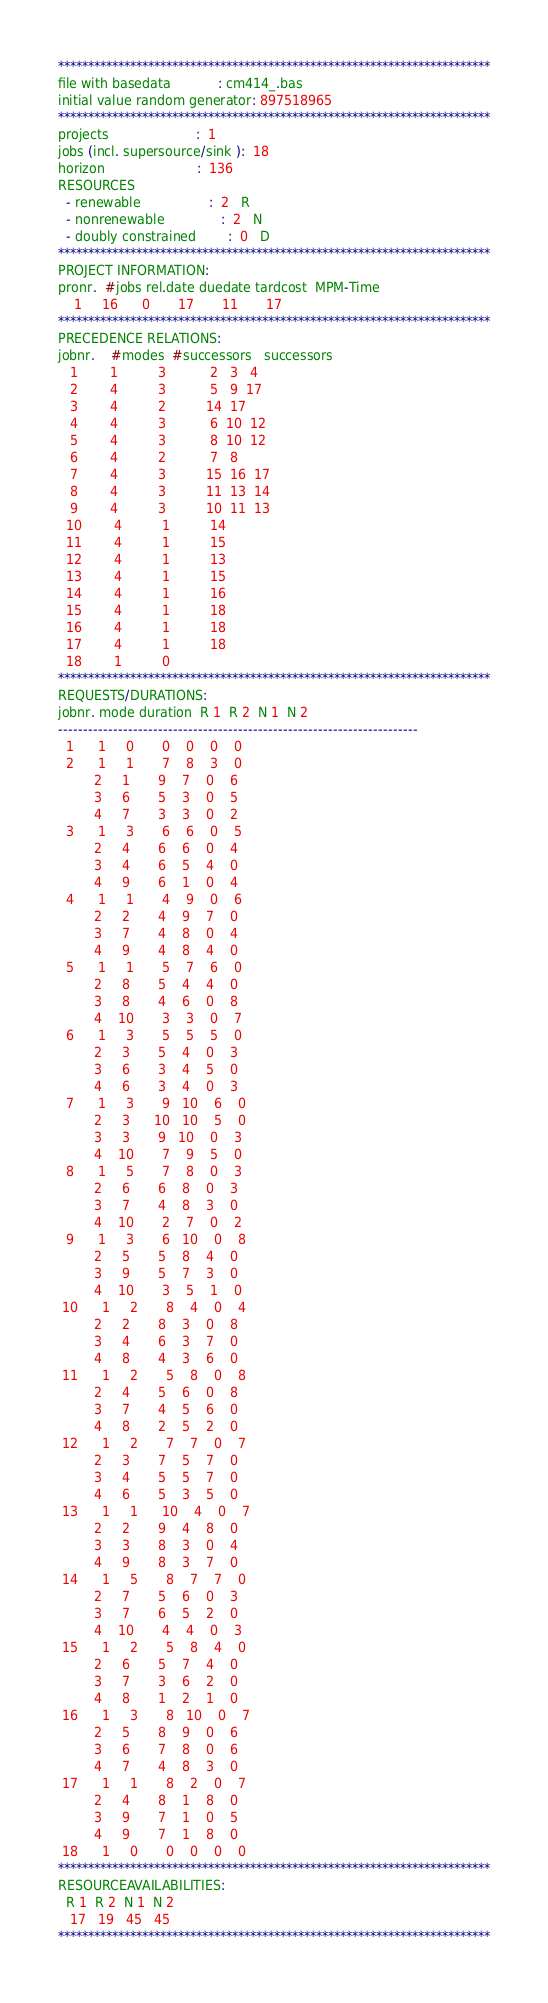<code> <loc_0><loc_0><loc_500><loc_500><_ObjectiveC_>************************************************************************
file with basedata            : cm414_.bas
initial value random generator: 897518965
************************************************************************
projects                      :  1
jobs (incl. supersource/sink ):  18
horizon                       :  136
RESOURCES
  - renewable                 :  2   R
  - nonrenewable              :  2   N
  - doubly constrained        :  0   D
************************************************************************
PROJECT INFORMATION:
pronr.  #jobs rel.date duedate tardcost  MPM-Time
    1     16      0       17       11       17
************************************************************************
PRECEDENCE RELATIONS:
jobnr.    #modes  #successors   successors
   1        1          3           2   3   4
   2        4          3           5   9  17
   3        4          2          14  17
   4        4          3           6  10  12
   5        4          3           8  10  12
   6        4          2           7   8
   7        4          3          15  16  17
   8        4          3          11  13  14
   9        4          3          10  11  13
  10        4          1          14
  11        4          1          15
  12        4          1          13
  13        4          1          15
  14        4          1          16
  15        4          1          18
  16        4          1          18
  17        4          1          18
  18        1          0        
************************************************************************
REQUESTS/DURATIONS:
jobnr. mode duration  R 1  R 2  N 1  N 2
------------------------------------------------------------------------
  1      1     0       0    0    0    0
  2      1     1       7    8    3    0
         2     1       9    7    0    6
         3     6       5    3    0    5
         4     7       3    3    0    2
  3      1     3       6    6    0    5
         2     4       6    6    0    4
         3     4       6    5    4    0
         4     9       6    1    0    4
  4      1     1       4    9    0    6
         2     2       4    9    7    0
         3     7       4    8    0    4
         4     9       4    8    4    0
  5      1     1       5    7    6    0
         2     8       5    4    4    0
         3     8       4    6    0    8
         4    10       3    3    0    7
  6      1     3       5    5    5    0
         2     3       5    4    0    3
         3     6       3    4    5    0
         4     6       3    4    0    3
  7      1     3       9   10    6    0
         2     3      10   10    5    0
         3     3       9   10    0    3
         4    10       7    9    5    0
  8      1     5       7    8    0    3
         2     6       6    8    0    3
         3     7       4    8    3    0
         4    10       2    7    0    2
  9      1     3       6   10    0    8
         2     5       5    8    4    0
         3     9       5    7    3    0
         4    10       3    5    1    0
 10      1     2       8    4    0    4
         2     2       8    3    0    8
         3     4       6    3    7    0
         4     8       4    3    6    0
 11      1     2       5    8    0    8
         2     4       5    6    0    8
         3     7       4    5    6    0
         4     8       2    5    2    0
 12      1     2       7    7    0    7
         2     3       7    5    7    0
         3     4       5    5    7    0
         4     6       5    3    5    0
 13      1     1      10    4    0    7
         2     2       9    4    8    0
         3     3       8    3    0    4
         4     9       8    3    7    0
 14      1     5       8    7    7    0
         2     7       5    6    0    3
         3     7       6    5    2    0
         4    10       4    4    0    3
 15      1     2       5    8    4    0
         2     6       5    7    4    0
         3     7       3    6    2    0
         4     8       1    2    1    0
 16      1     3       8   10    0    7
         2     5       8    9    0    6
         3     6       7    8    0    6
         4     7       4    8    3    0
 17      1     1       8    2    0    7
         2     4       8    1    8    0
         3     9       7    1    0    5
         4     9       7    1    8    0
 18      1     0       0    0    0    0
************************************************************************
RESOURCEAVAILABILITIES:
  R 1  R 2  N 1  N 2
   17   19   45   45
************************************************************************
</code> 